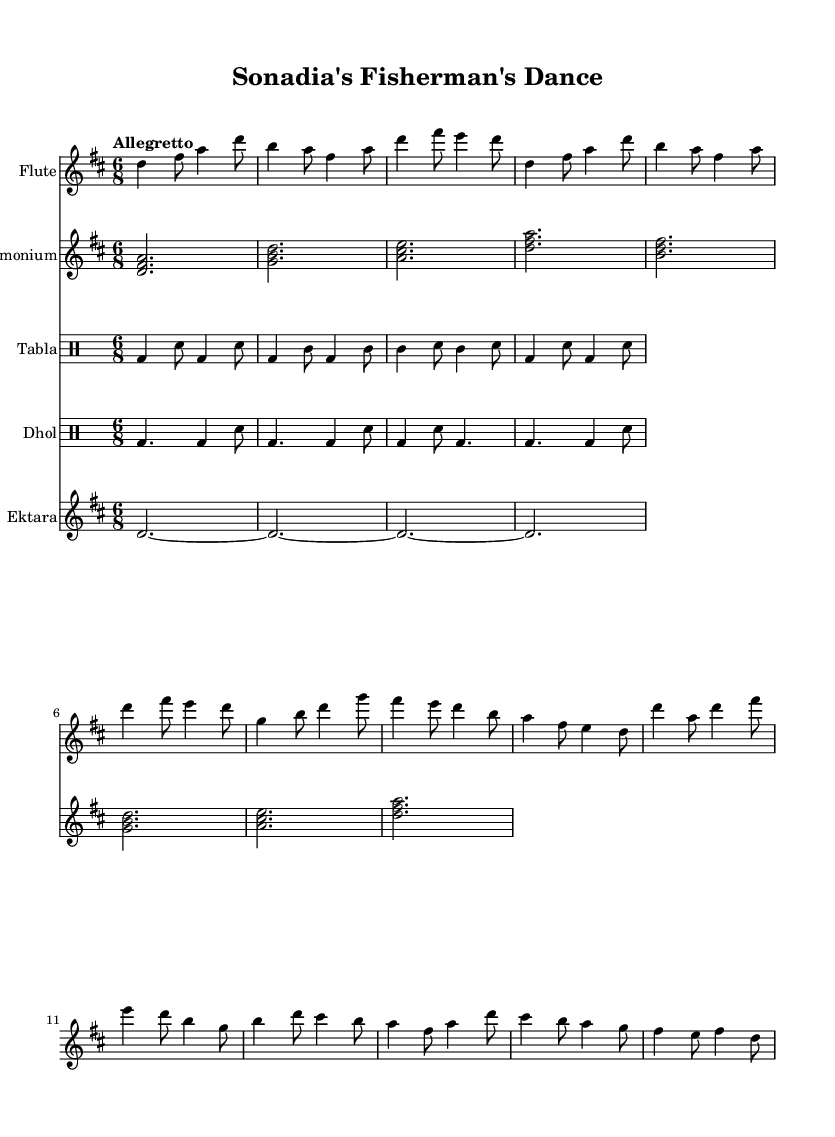What is the key signature of this music? The key signature is located at the beginning of the staff, indicating that this piece is in D major, which has two sharps (F# and C#).
Answer: D major What is the time signature of the piece? The time signature is found at the beginning of the sheet music, indicating that the piece is in 6/8 time, meaning there are six beats in each measure and the eighth note gets one beat.
Answer: 6/8 What is the tempo marking for this piece? The tempo marking is noted on the sheet, showing that the piece should be played at an 'Allegretto' speed, which typically is moderately fast.
Answer: Allegretto How many measures are in the flute part? By counting the measures within the flute part, there are a total of 16 measures included in the music.
Answer: 16 What instruments are featured in this composition? The sheet music lists four different staves for instruments: Flute, Harmonium, Tabla, Dhol, and Ektara, showcasing a diverse range of instrumentation for the dance.
Answer: Flute, Harmonium, Tabla, Dhol, Ektara What type of dance does this music represent? The title of the sheet music, "Sonadia's Fisherman's Dance," indicates that this music is specifically created for a traditional Bengali folk dance celebrating coastal life.
Answer: Fisherman's Dance 